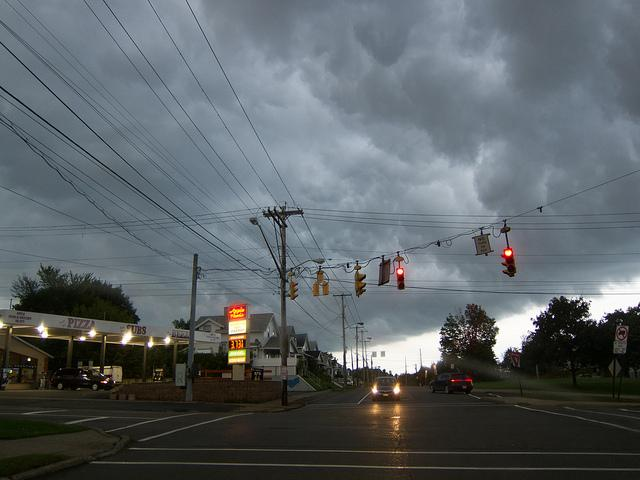What type of station is in view? gas 